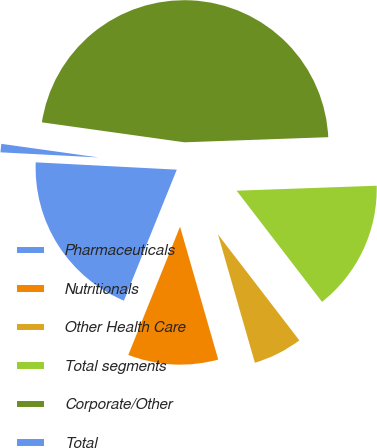Convert chart to OTSL. <chart><loc_0><loc_0><loc_500><loc_500><pie_chart><fcel>Pharmaceuticals<fcel>Nutritionals<fcel>Other Health Care<fcel>Total segments<fcel>Corporate/Other<fcel>Total<nl><fcel>19.72%<fcel>10.56%<fcel>5.97%<fcel>15.14%<fcel>47.22%<fcel>1.39%<nl></chart> 